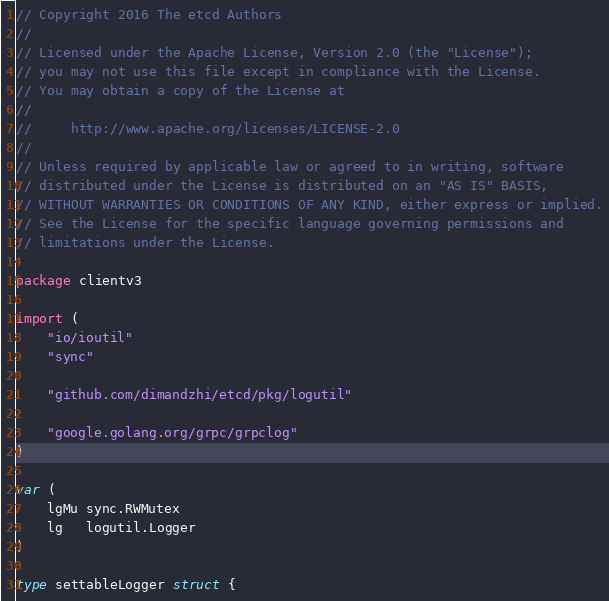Convert code to text. <code><loc_0><loc_0><loc_500><loc_500><_Go_>// Copyright 2016 The etcd Authors
//
// Licensed under the Apache License, Version 2.0 (the "License");
// you may not use this file except in compliance with the License.
// You may obtain a copy of the License at
//
//     http://www.apache.org/licenses/LICENSE-2.0
//
// Unless required by applicable law or agreed to in writing, software
// distributed under the License is distributed on an "AS IS" BASIS,
// WITHOUT WARRANTIES OR CONDITIONS OF ANY KIND, either express or implied.
// See the License for the specific language governing permissions and
// limitations under the License.

package clientv3

import (
	"io/ioutil"
	"sync"

	"github.com/dimandzhi/etcd/pkg/logutil"

	"google.golang.org/grpc/grpclog"
)

var (
	lgMu sync.RWMutex
	lg   logutil.Logger
)

type settableLogger struct {</code> 